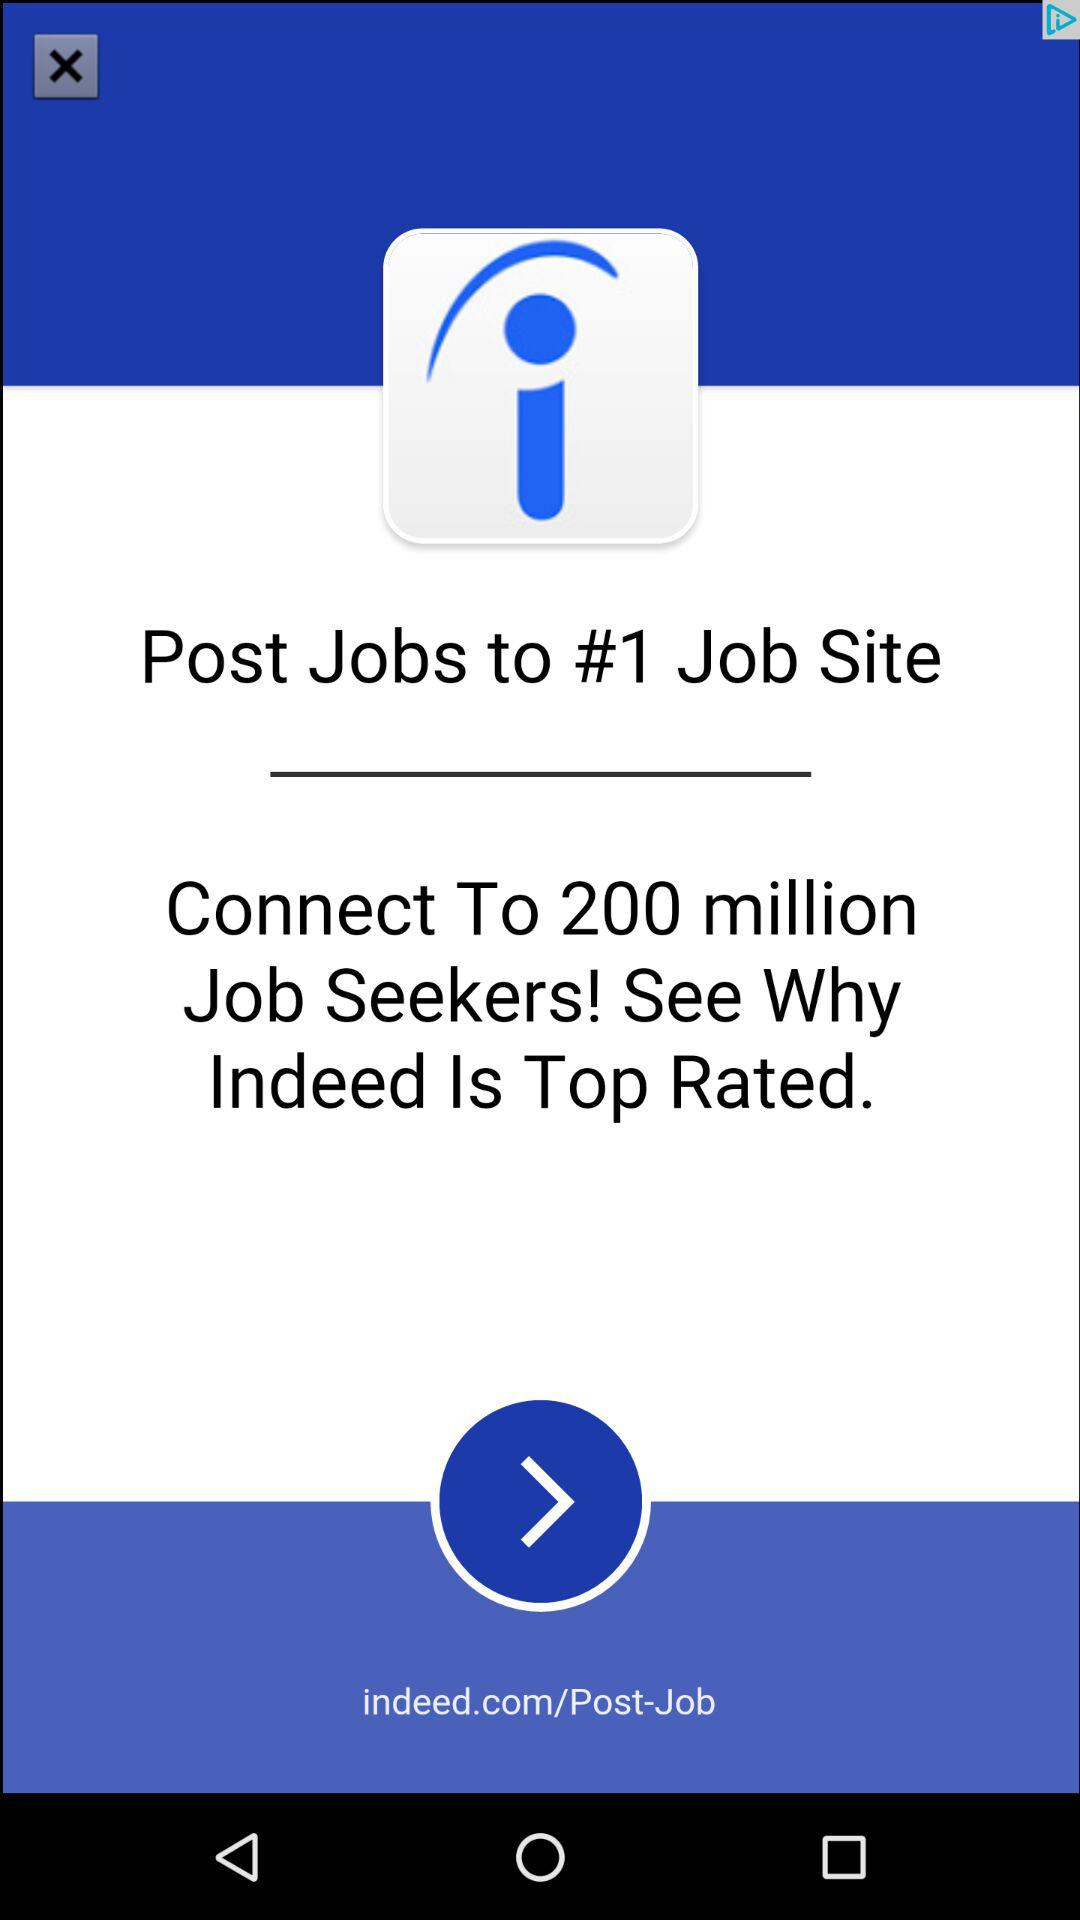What is the application name? The application name is "Indeed". 